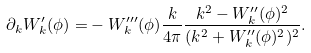Convert formula to latex. <formula><loc_0><loc_0><loc_500><loc_500>\partial _ { k } W ^ { \prime } _ { k } ( \phi ) = & - W _ { k } ^ { \prime \prime \prime } ( \phi ) \frac { k } { 4 \pi } \frac { k ^ { 2 } - W _ { k } ^ { \prime \prime } ( \phi ) ^ { 2 } } { ( k ^ { 2 } + W _ { k } ^ { \prime \prime } ( \phi ) ^ { 2 } ) ^ { 2 } } .</formula> 